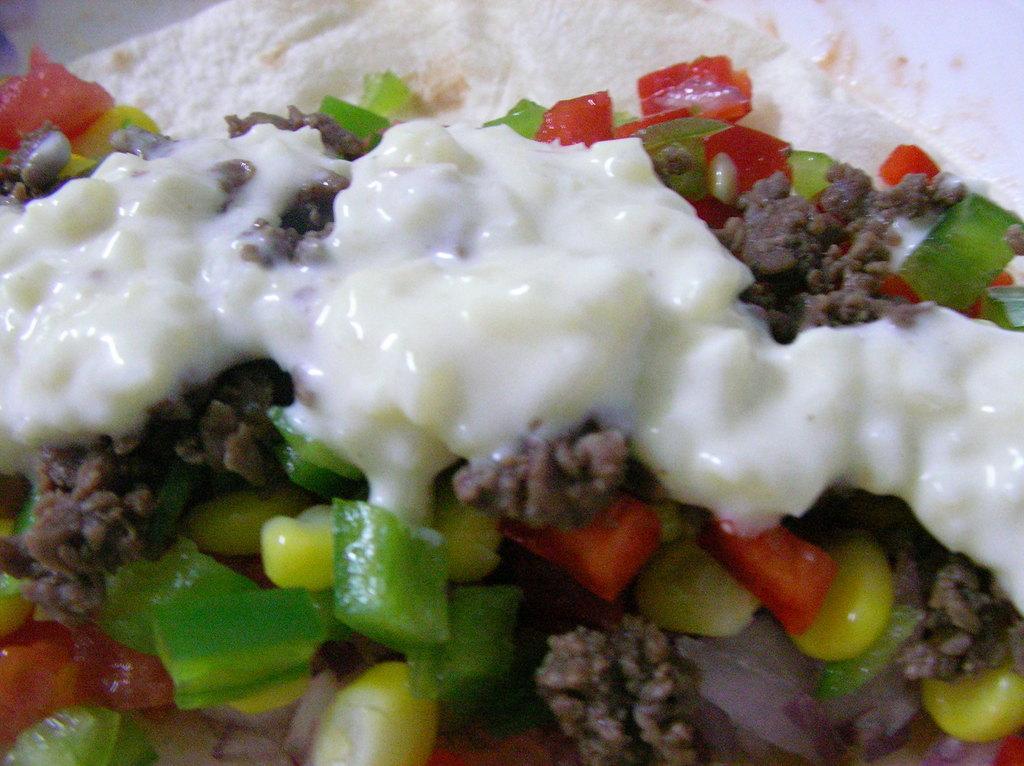Describe this image in one or two sentences. In this image on a plate there is some food. There is chopped capsicum, sweet corn, minced meat is there on the plate. 